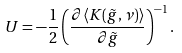<formula> <loc_0><loc_0><loc_500><loc_500>U = - \frac { 1 } { 2 } \left ( \frac { \partial \langle K ( \tilde { g } , \nu ) \rangle } { \partial \tilde { g } } \right ) ^ { - 1 } .</formula> 